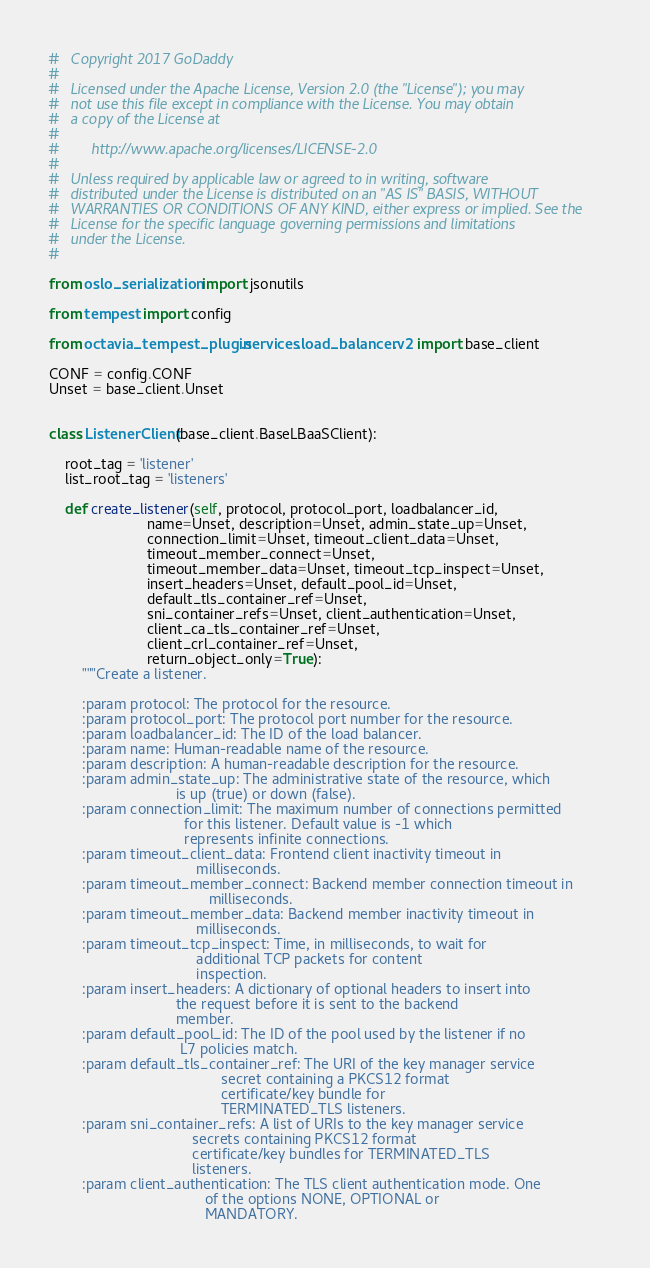Convert code to text. <code><loc_0><loc_0><loc_500><loc_500><_Python_>#   Copyright 2017 GoDaddy
#
#   Licensed under the Apache License, Version 2.0 (the "License"); you may
#   not use this file except in compliance with the License. You may obtain
#   a copy of the License at
#
#        http://www.apache.org/licenses/LICENSE-2.0
#
#   Unless required by applicable law or agreed to in writing, software
#   distributed under the License is distributed on an "AS IS" BASIS, WITHOUT
#   WARRANTIES OR CONDITIONS OF ANY KIND, either express or implied. See the
#   License for the specific language governing permissions and limitations
#   under the License.
#

from oslo_serialization import jsonutils

from tempest import config

from octavia_tempest_plugin.services.load_balancer.v2 import base_client

CONF = config.CONF
Unset = base_client.Unset


class ListenerClient(base_client.BaseLBaaSClient):

    root_tag = 'listener'
    list_root_tag = 'listeners'

    def create_listener(self, protocol, protocol_port, loadbalancer_id,
                        name=Unset, description=Unset, admin_state_up=Unset,
                        connection_limit=Unset, timeout_client_data=Unset,
                        timeout_member_connect=Unset,
                        timeout_member_data=Unset, timeout_tcp_inspect=Unset,
                        insert_headers=Unset, default_pool_id=Unset,
                        default_tls_container_ref=Unset,
                        sni_container_refs=Unset, client_authentication=Unset,
                        client_ca_tls_container_ref=Unset,
                        client_crl_container_ref=Unset,
                        return_object_only=True):
        """Create a listener.

        :param protocol: The protocol for the resource.
        :param protocol_port: The protocol port number for the resource.
        :param loadbalancer_id: The ID of the load balancer.
        :param name: Human-readable name of the resource.
        :param description: A human-readable description for the resource.
        :param admin_state_up: The administrative state of the resource, which
                               is up (true) or down (false).
        :param connection_limit: The maximum number of connections permitted
                                 for this listener. Default value is -1 which
                                 represents infinite connections.
        :param timeout_client_data: Frontend client inactivity timeout in
                                    milliseconds.
        :param timeout_member_connect: Backend member connection timeout in
                                       milliseconds.
        :param timeout_member_data: Backend member inactivity timeout in
                                    milliseconds.
        :param timeout_tcp_inspect: Time, in milliseconds, to wait for
                                    additional TCP packets for content
                                    inspection.
        :param insert_headers: A dictionary of optional headers to insert into
                               the request before it is sent to the backend
                               member.
        :param default_pool_id: The ID of the pool used by the listener if no
                                L7 policies match.
        :param default_tls_container_ref: The URI of the key manager service
                                          secret containing a PKCS12 format
                                          certificate/key bundle for
                                          TERMINATED_TLS listeners.
        :param sni_container_refs: A list of URIs to the key manager service
                                   secrets containing PKCS12 format
                                   certificate/key bundles for TERMINATED_TLS
                                   listeners.
        :param client_authentication: The TLS client authentication mode. One
                                      of the options NONE, OPTIONAL or
                                      MANDATORY.</code> 